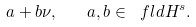<formula> <loc_0><loc_0><loc_500><loc_500>a + b \nu , \quad a , b \in \ f l d { H } ^ { s } .</formula> 